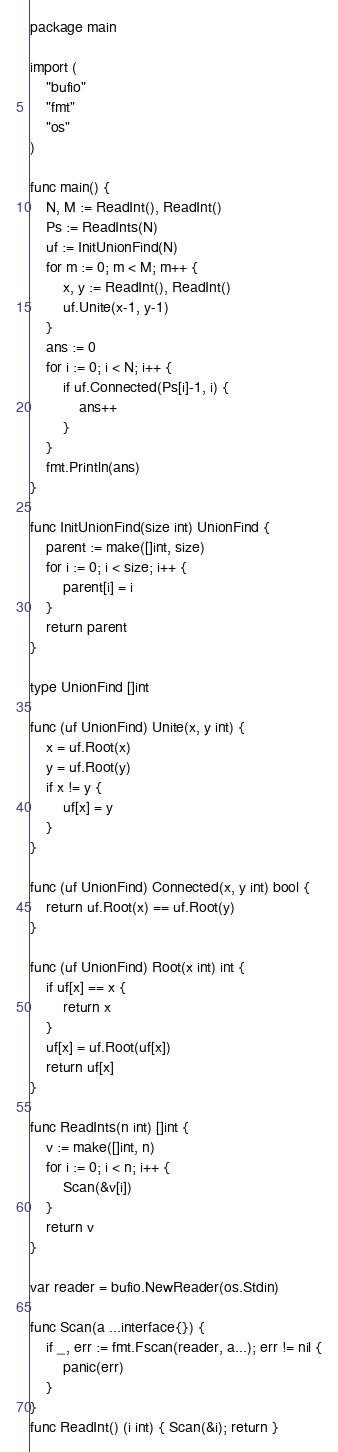Convert code to text. <code><loc_0><loc_0><loc_500><loc_500><_Go_>package main

import (
	"bufio"
	"fmt"
	"os"
)

func main() {
	N, M := ReadInt(), ReadInt()
	Ps := ReadInts(N)
	uf := InitUnionFind(N)
	for m := 0; m < M; m++ {
		x, y := ReadInt(), ReadInt()
		uf.Unite(x-1, y-1)
	}
	ans := 0
	for i := 0; i < N; i++ {
		if uf.Connected(Ps[i]-1, i) {
			ans++
		}
	}
	fmt.Println(ans)
}

func InitUnionFind(size int) UnionFind {
	parent := make([]int, size)
	for i := 0; i < size; i++ {
		parent[i] = i
	}
	return parent
}

type UnionFind []int

func (uf UnionFind) Unite(x, y int) {
	x = uf.Root(x)
	y = uf.Root(y)
	if x != y {
		uf[x] = y
	}
}

func (uf UnionFind) Connected(x, y int) bool {
	return uf.Root(x) == uf.Root(y)
}

func (uf UnionFind) Root(x int) int {
	if uf[x] == x {
		return x
	}
	uf[x] = uf.Root(uf[x])
	return uf[x]
}

func ReadInts(n int) []int {
	v := make([]int, n)
	for i := 0; i < n; i++ {
		Scan(&v[i])
	}
	return v
}

var reader = bufio.NewReader(os.Stdin)

func Scan(a ...interface{}) {
	if _, err := fmt.Fscan(reader, a...); err != nil {
		panic(err)
	}
}
func ReadInt() (i int) { Scan(&i); return }
</code> 